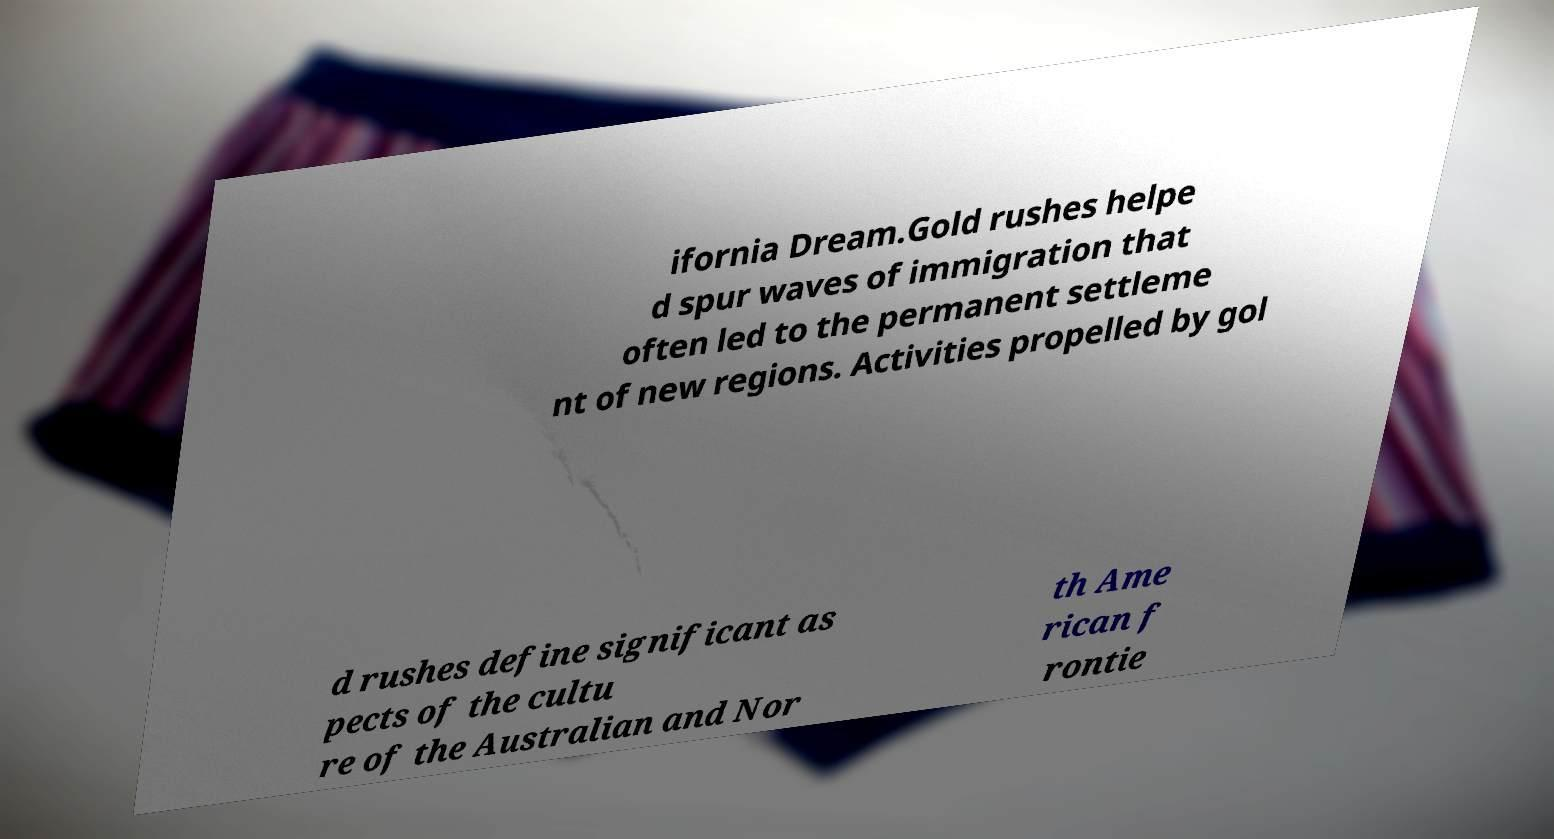I need the written content from this picture converted into text. Can you do that? ifornia Dream.Gold rushes helpe d spur waves of immigration that often led to the permanent settleme nt of new regions. Activities propelled by gol d rushes define significant as pects of the cultu re of the Australian and Nor th Ame rican f rontie 